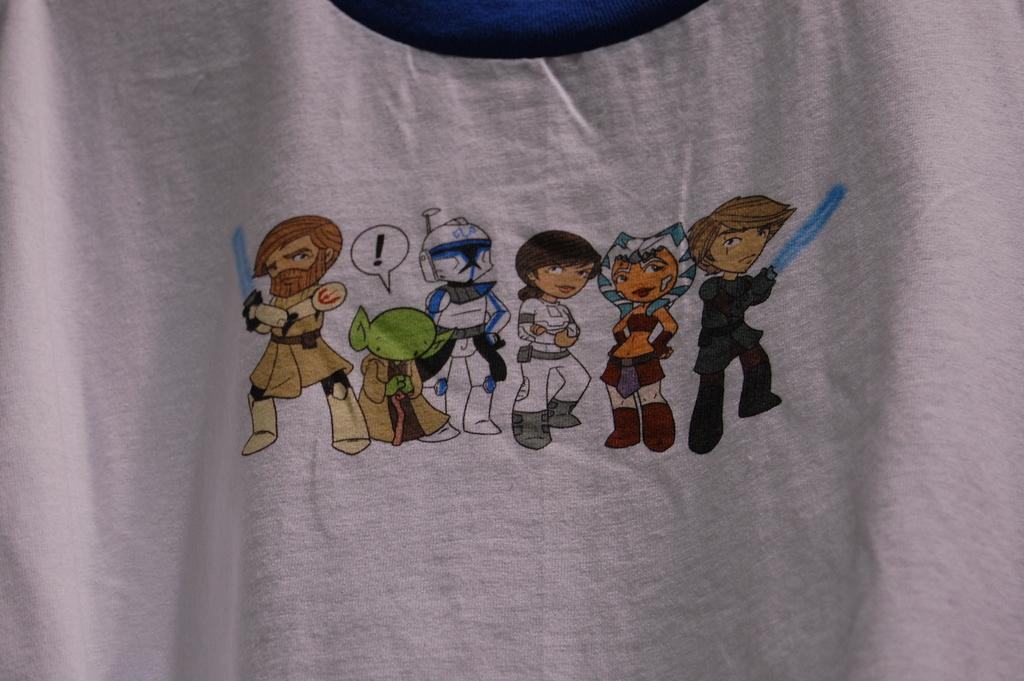What color is the cloth in the image? The cloth in the image is white. What is depicted on the white cloth? There are cartoon images on the white cloth. What type of waste is being disposed of in the image? There is no waste present in the image; it features a white cloth with cartoon images. What kind of apparatus is being used to create the cartoon images on the cloth? There is no apparatus visible in the image; it only shows the white cloth with cartoon images. 